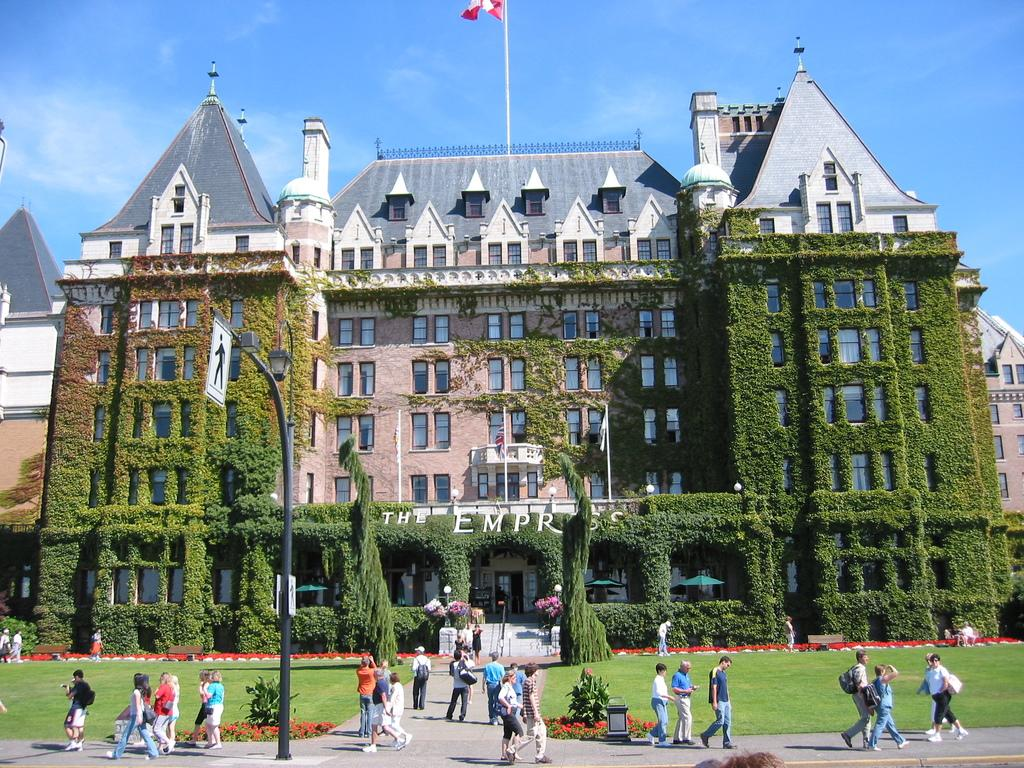What is happening with the group of people in the image? The people are walking in the image. What can be seen in the background of the image? There is a building and many trees in the image. Are there any plants visible in the image? Yes, there are plants in the image. Can you tell me what type of stamp is on the giraffe's forehead in the image? There is no giraffe or stamp present in the image. What color is the robin's beak in the image? There is no robin present in the image. 